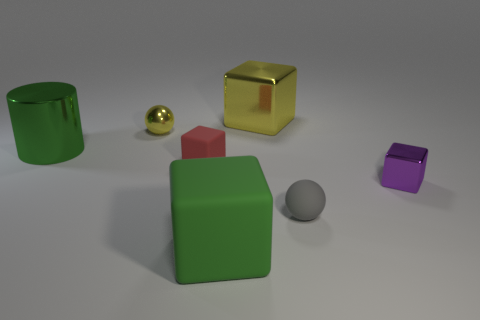How big is the matte cube to the left of the green object that is in front of the green shiny cylinder? The matte cube to the left of the green object, which is positioned in front of the shiny green cylinder, appears to be relatively small in size, especially when compared to the objects around it. 